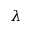Convert formula to latex. <formula><loc_0><loc_0><loc_500><loc_500>\lambda</formula> 